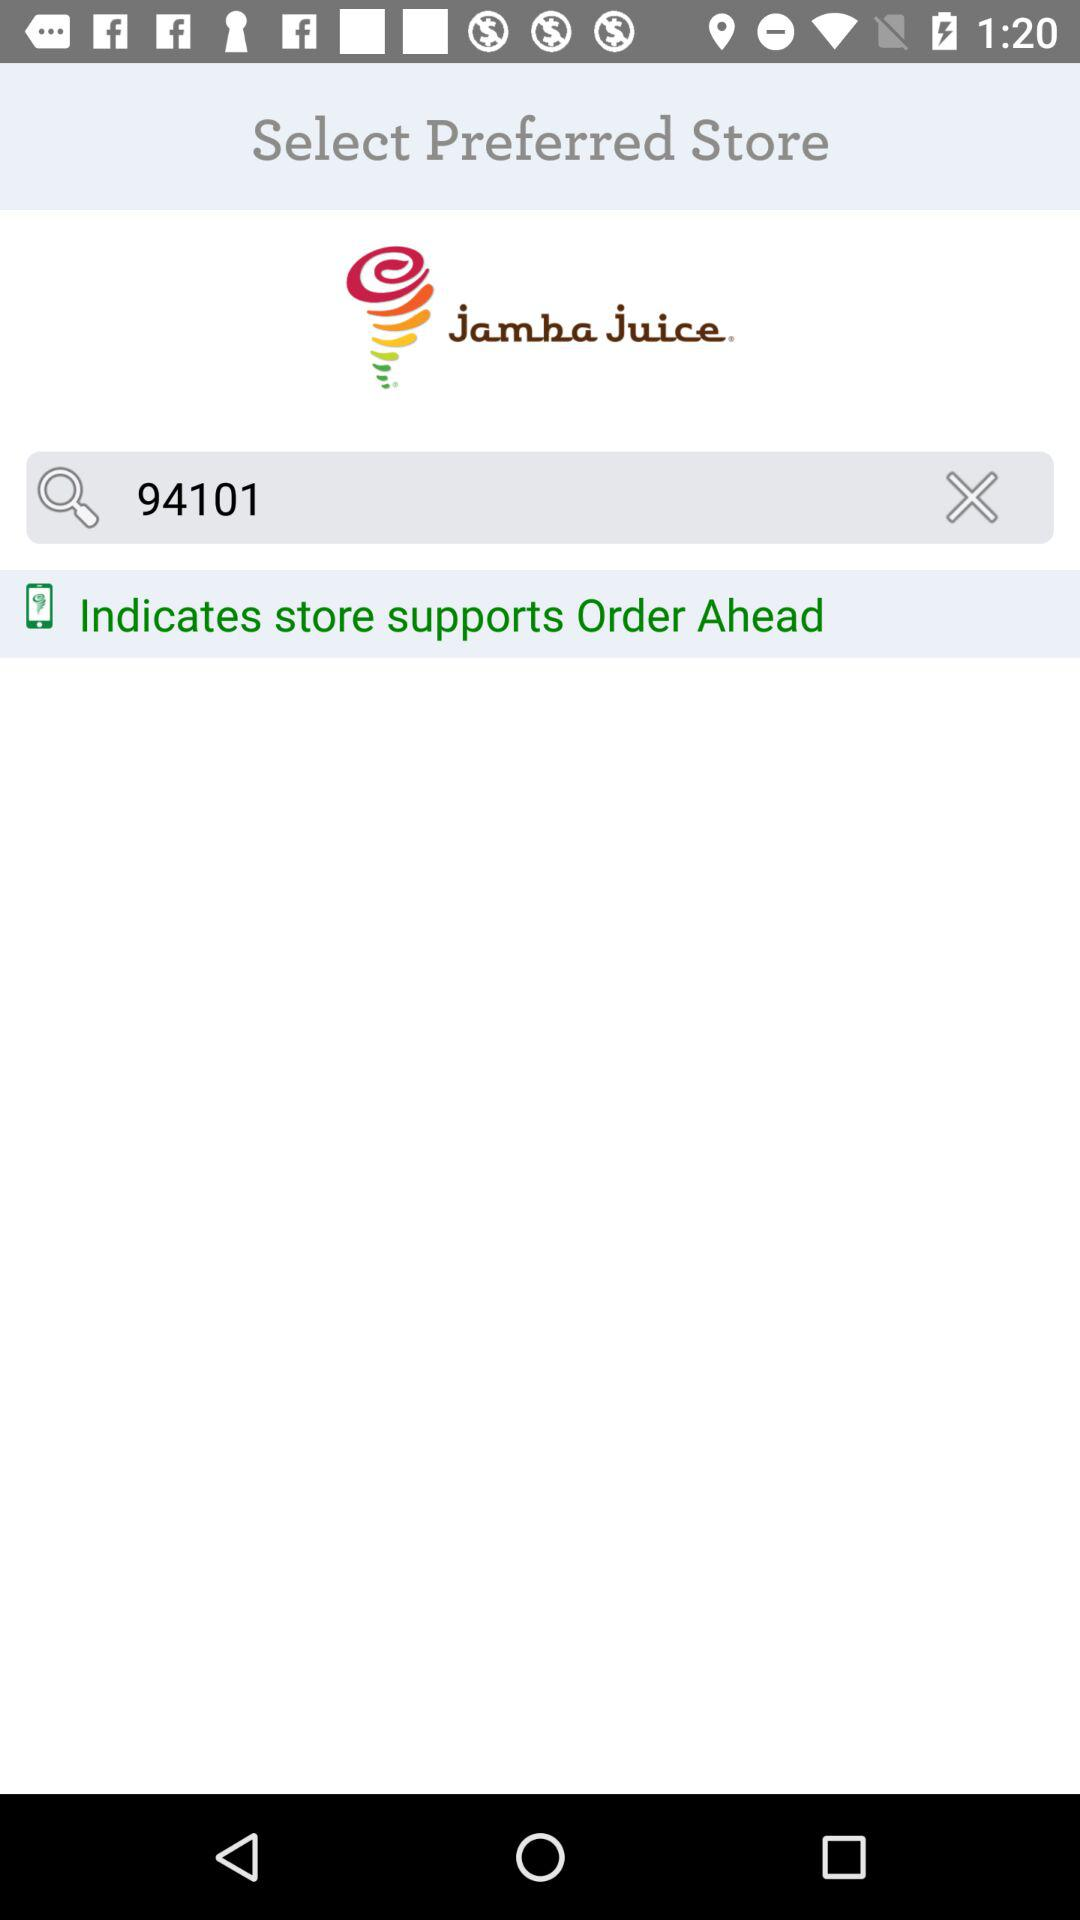What is the name of the store? The name of the store is "jamba juice". 